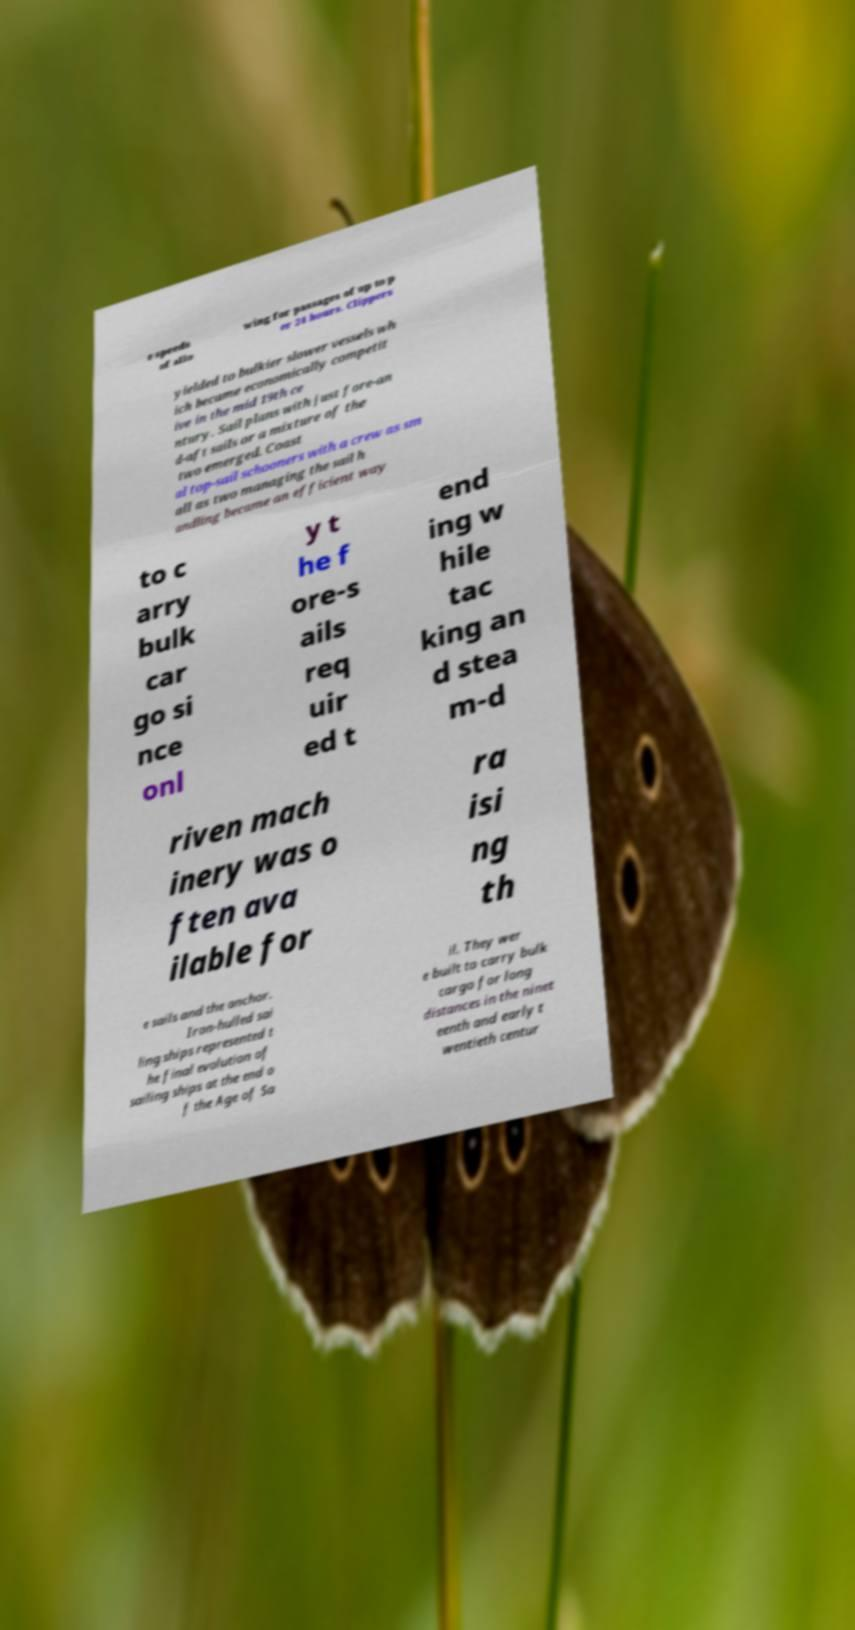Please read and relay the text visible in this image. What does it say? e speeds of allo wing for passages of up to p er 24 hours. Clippers yielded to bulkier slower vessels wh ich became economically competit ive in the mid 19th ce ntury. Sail plans with just fore-an d-aft sails or a mixture of the two emerged. Coast al top-sail schooners with a crew as sm all as two managing the sail h andling became an efficient way to c arry bulk car go si nce onl y t he f ore-s ails req uir ed t end ing w hile tac king an d stea m-d riven mach inery was o ften ava ilable for ra isi ng th e sails and the anchor. Iron-hulled sai ling ships represented t he final evolution of sailing ships at the end o f the Age of Sa il. They wer e built to carry bulk cargo for long distances in the ninet eenth and early t wentieth centur 